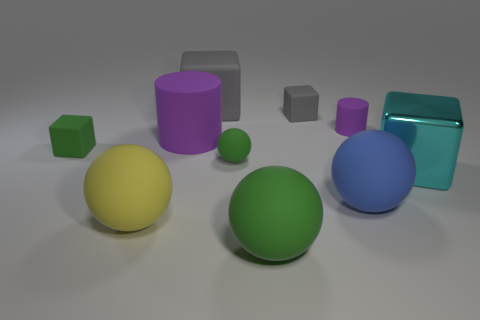Subtract all big balls. How many balls are left? 1 Subtract all cylinders. How many objects are left? 8 Subtract all gray blocks. How many blocks are left? 2 Subtract 1 cylinders. How many cylinders are left? 1 Subtract all yellow blocks. How many green spheres are left? 2 Add 6 big shiny blocks. How many big shiny blocks exist? 7 Subtract 0 red balls. How many objects are left? 10 Subtract all gray blocks. Subtract all yellow spheres. How many blocks are left? 2 Subtract all large green rubber spheres. Subtract all small purple rubber balls. How many objects are left? 9 Add 6 large yellow matte spheres. How many large yellow matte spheres are left? 7 